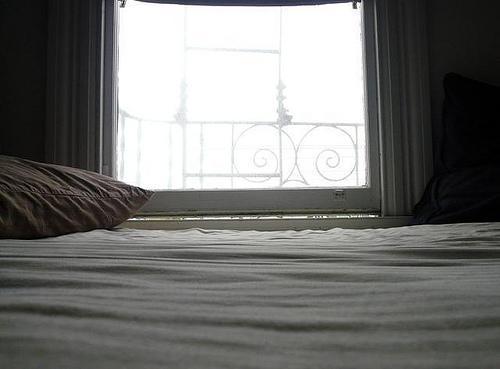How many boxes of pizza are on the bed?
Give a very brief answer. 0. 